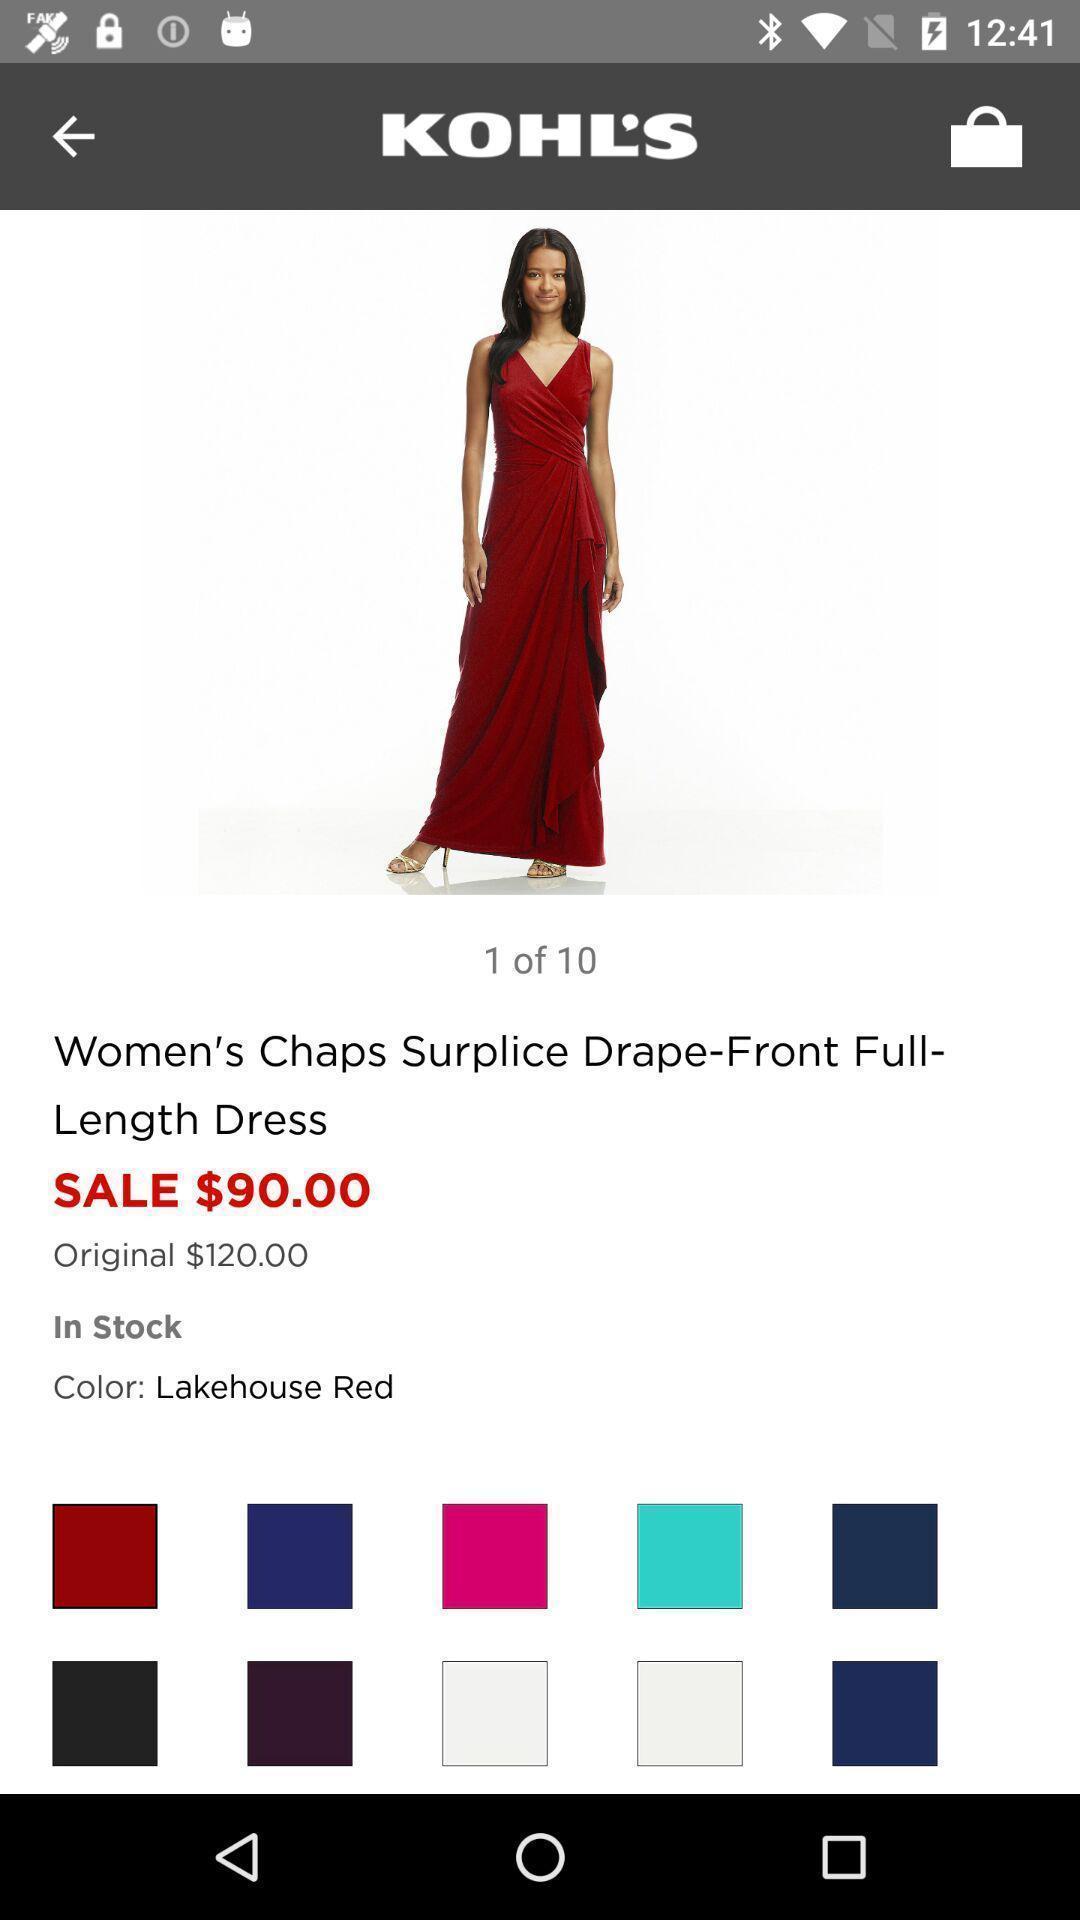Provide a textual representation of this image. Screen displaying the product in a shopping app. 